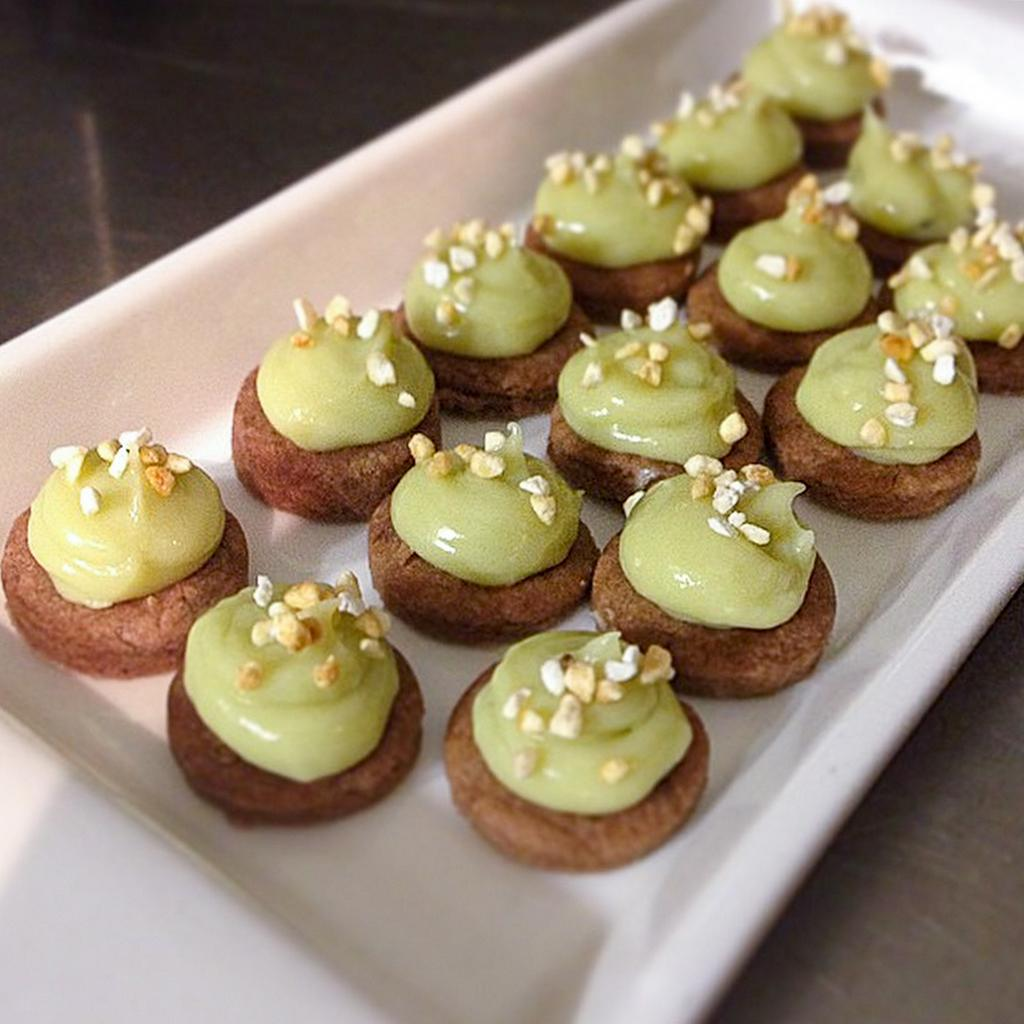What is the main object in the image? There is a table in the image. What is placed on the table? There are food items in a tray on top of the table. How many chickens are sitting on the chairs in the image? There are no chickens or chairs present in the image. 